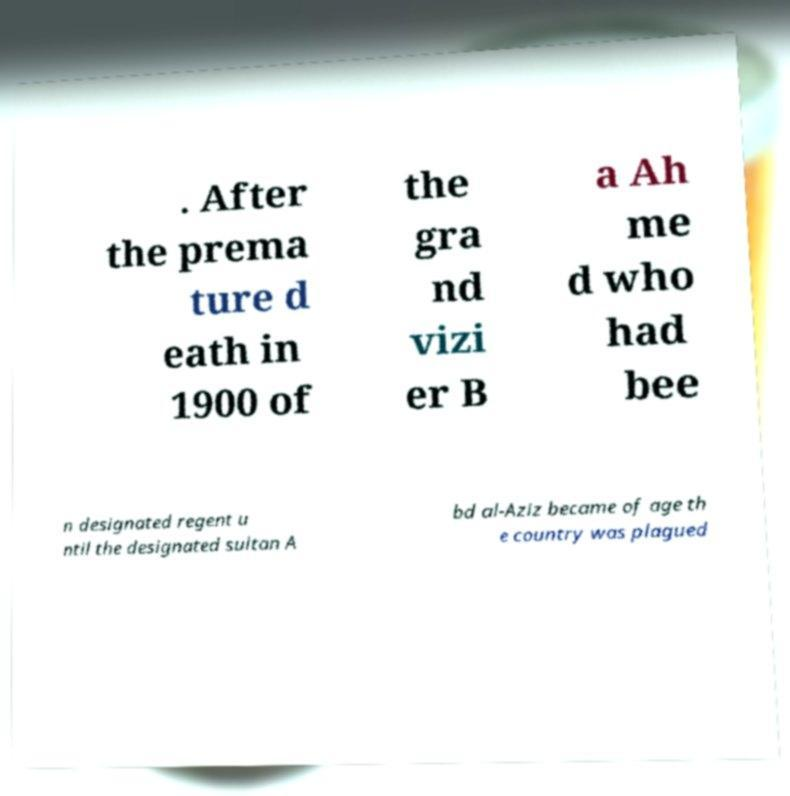Please identify and transcribe the text found in this image. . After the prema ture d eath in 1900 of the gra nd vizi er B a Ah me d who had bee n designated regent u ntil the designated sultan A bd al-Aziz became of age th e country was plagued 